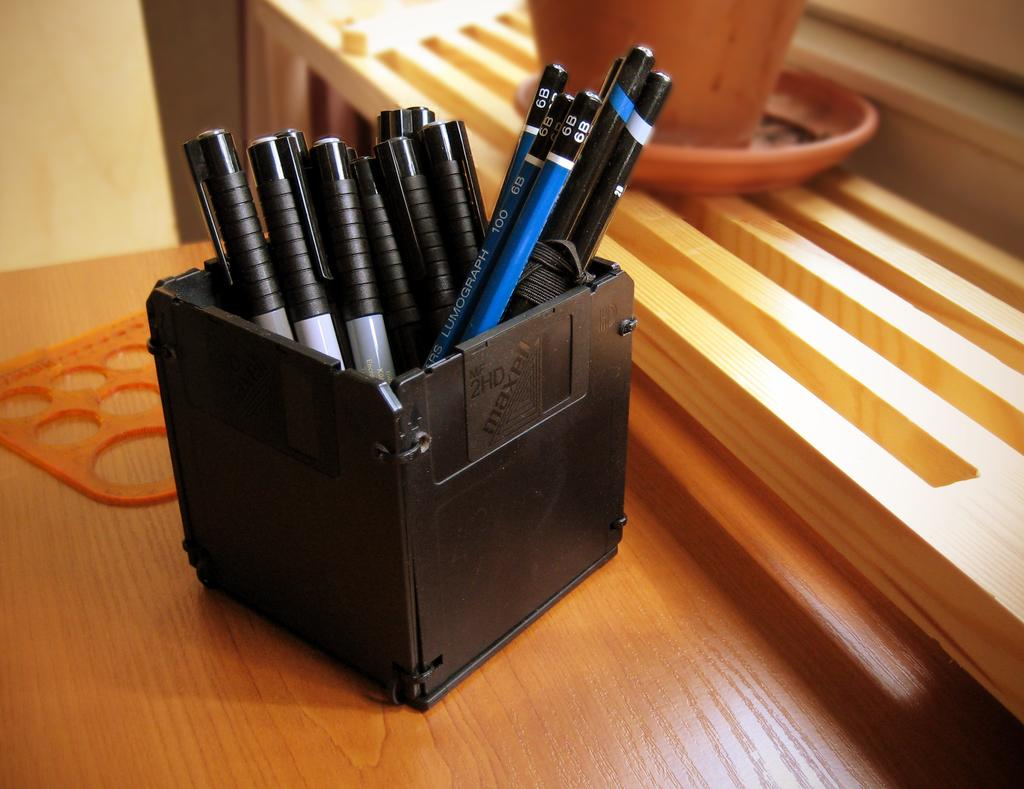What writing instruments are visible in the image? There are pens and pencils in the image. How are the pens and pencils organized or stored in the image? The pens and pencils are in a box. Where is the box with the pens and pencils located? The box is on a table. What type of teeth can be seen on the pencils in the image? There are no teeth visible on the pencils in the image, as pencils do not have teeth. 